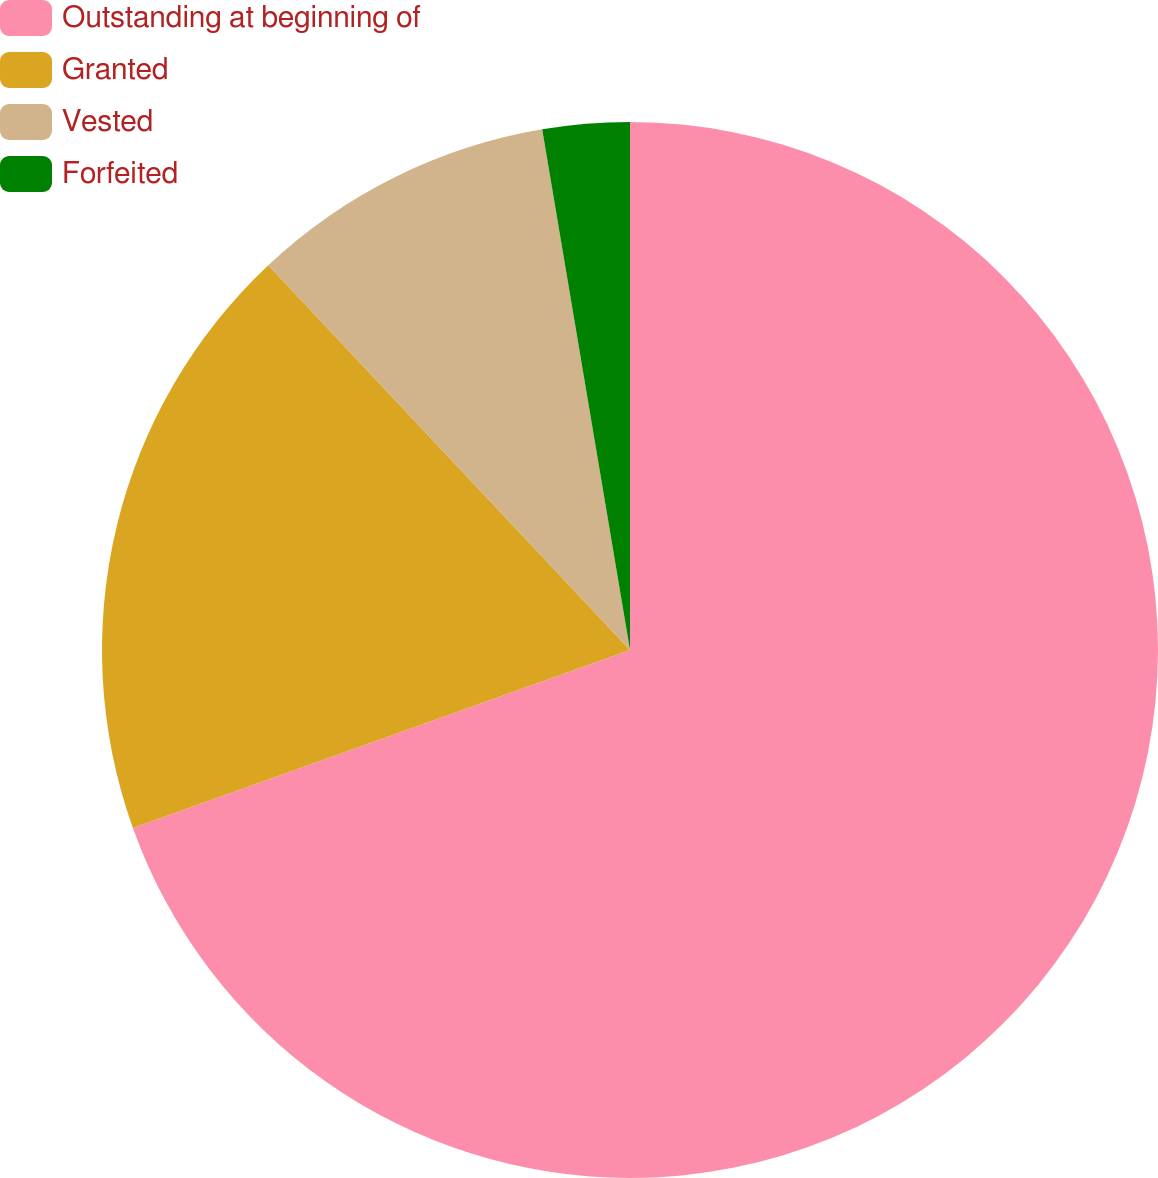<chart> <loc_0><loc_0><loc_500><loc_500><pie_chart><fcel>Outstanding at beginning of<fcel>Granted<fcel>Vested<fcel>Forfeited<nl><fcel>69.53%<fcel>18.46%<fcel>9.35%<fcel>2.66%<nl></chart> 